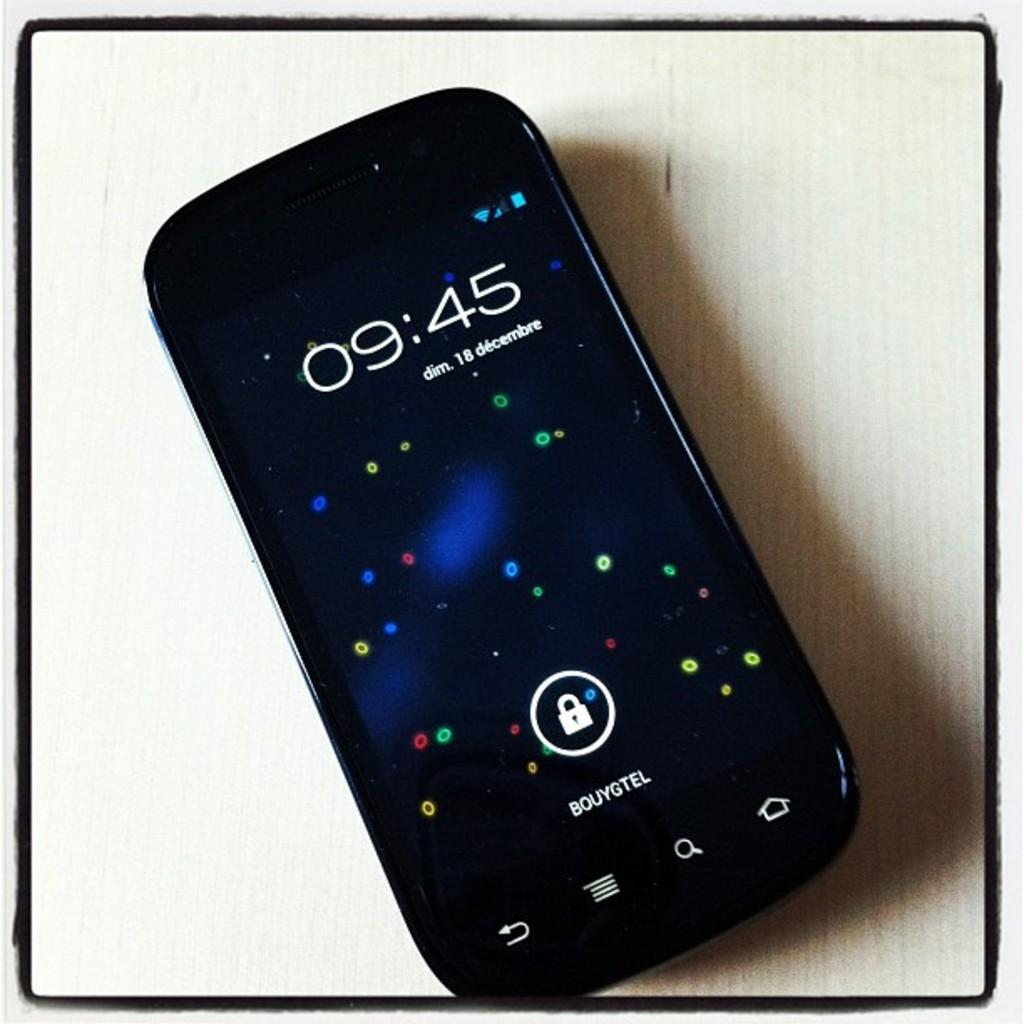<image>
Present a compact description of the photo's key features. A cell phone displays the time 09:45 on its screen. 